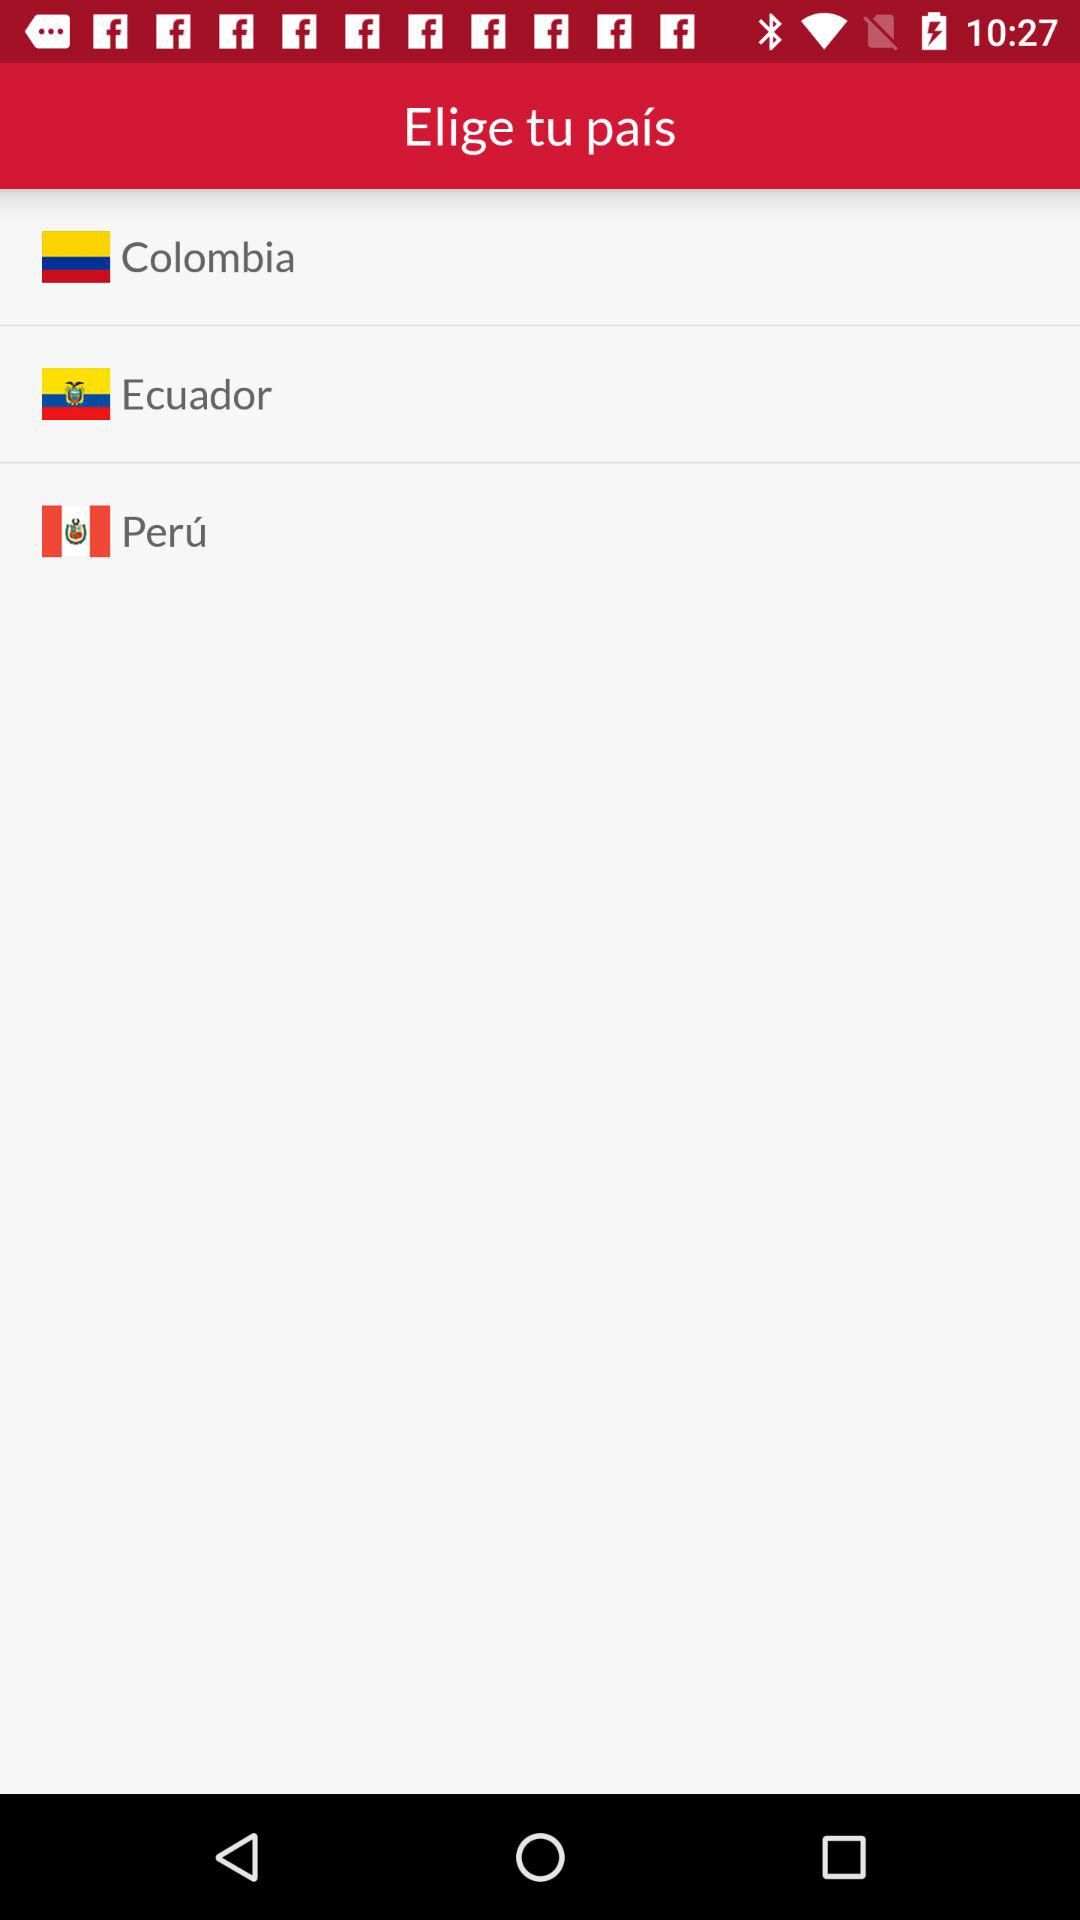How many countries are available to select?
Answer the question using a single word or phrase. 3 